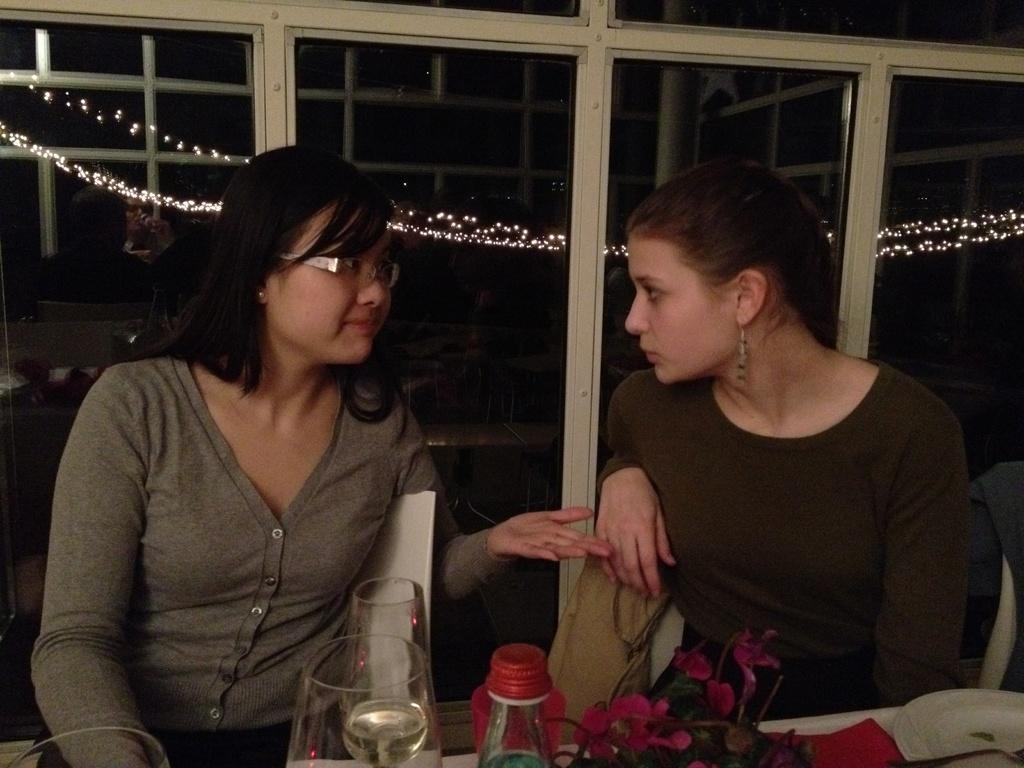How many women are in the image? There are two women in the image. What are the women doing in the image? The women are sitting on chairs. What is present on the table in the image? There are glasses on the table. What can be seen in the background of the image? There are glass windows in the background of the image. What type of jewel is the woman holding in her hand in the image? There is no jewel present in the image; the women are sitting on chairs and there are glasses on the table. 